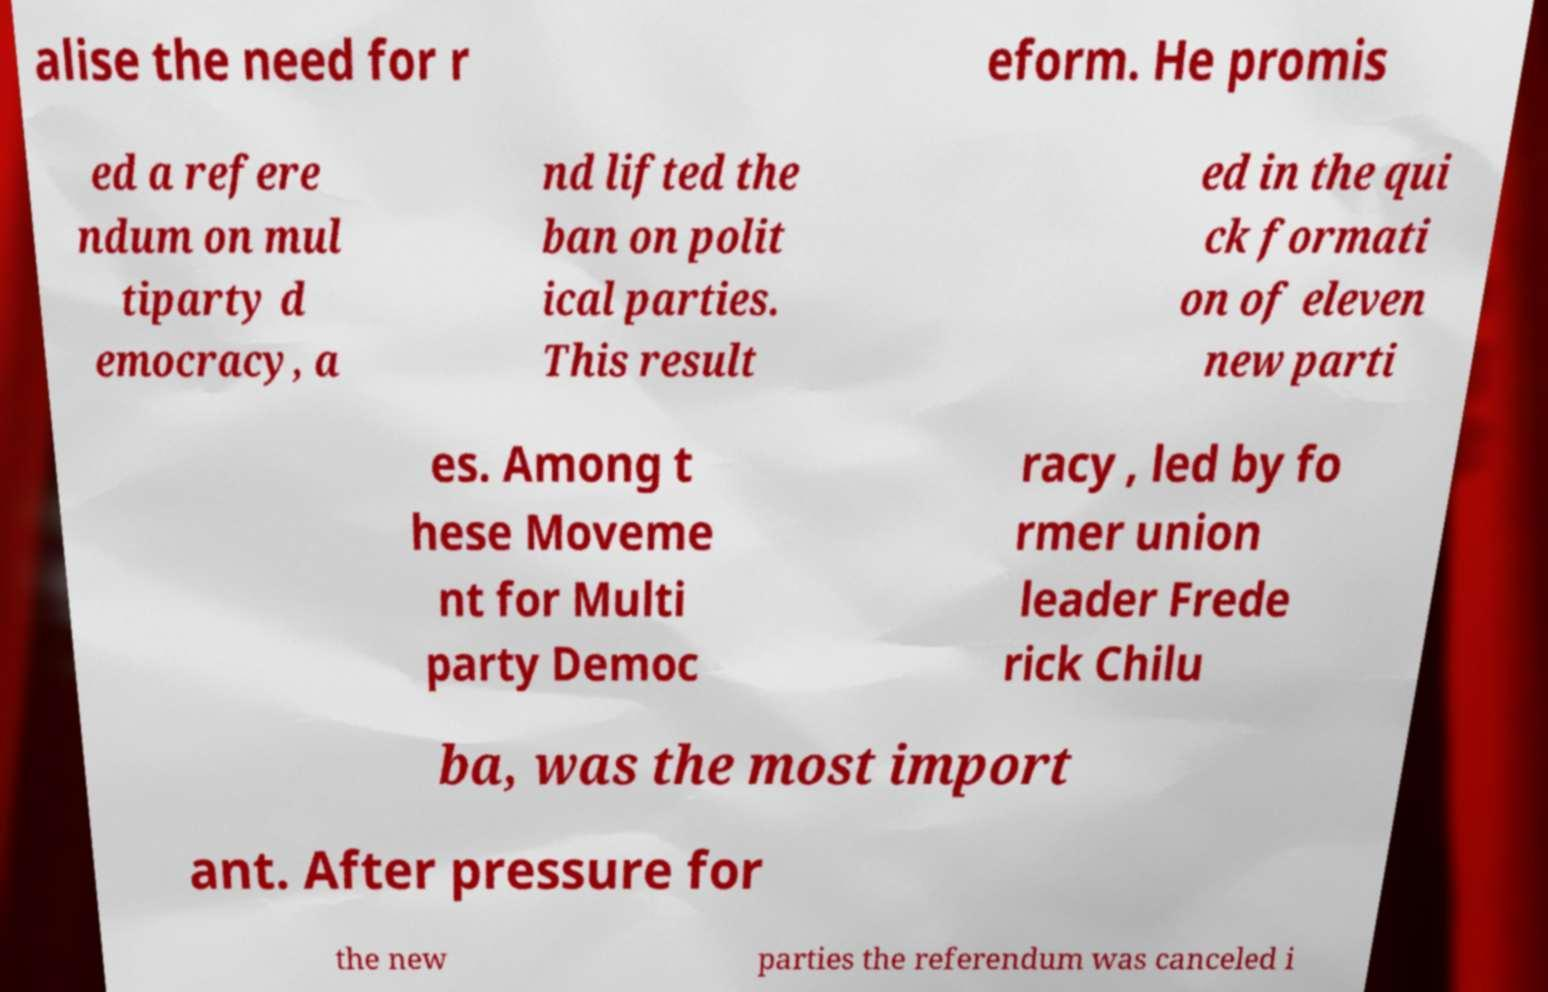Could you assist in decoding the text presented in this image and type it out clearly? alise the need for r eform. He promis ed a refere ndum on mul tiparty d emocracy, a nd lifted the ban on polit ical parties. This result ed in the qui ck formati on of eleven new parti es. Among t hese Moveme nt for Multi party Democ racy , led by fo rmer union leader Frede rick Chilu ba, was the most import ant. After pressure for the new parties the referendum was canceled i 